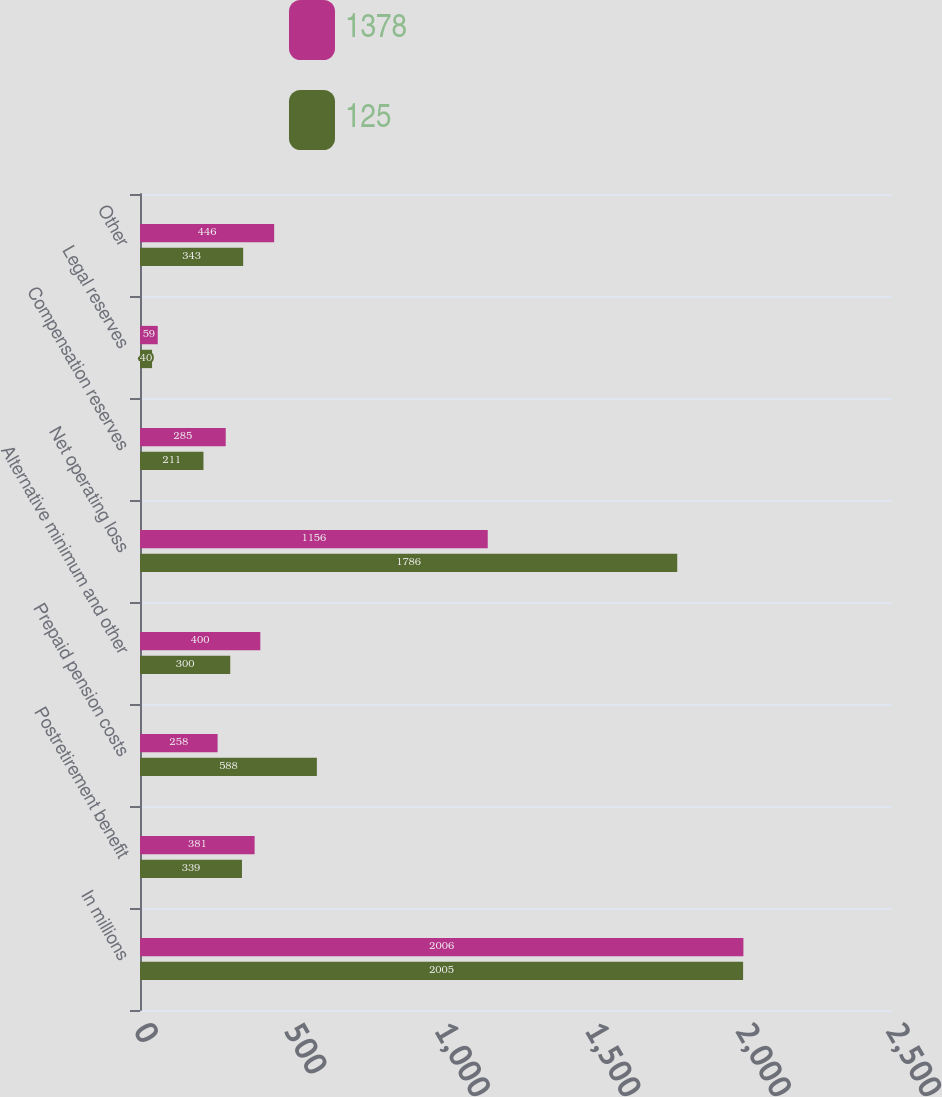<chart> <loc_0><loc_0><loc_500><loc_500><stacked_bar_chart><ecel><fcel>In millions<fcel>Postretirement benefit<fcel>Prepaid pension costs<fcel>Alternative minimum and other<fcel>Net operating loss<fcel>Compensation reserves<fcel>Legal reserves<fcel>Other<nl><fcel>1378<fcel>2006<fcel>381<fcel>258<fcel>400<fcel>1156<fcel>285<fcel>59<fcel>446<nl><fcel>125<fcel>2005<fcel>339<fcel>588<fcel>300<fcel>1786<fcel>211<fcel>40<fcel>343<nl></chart> 